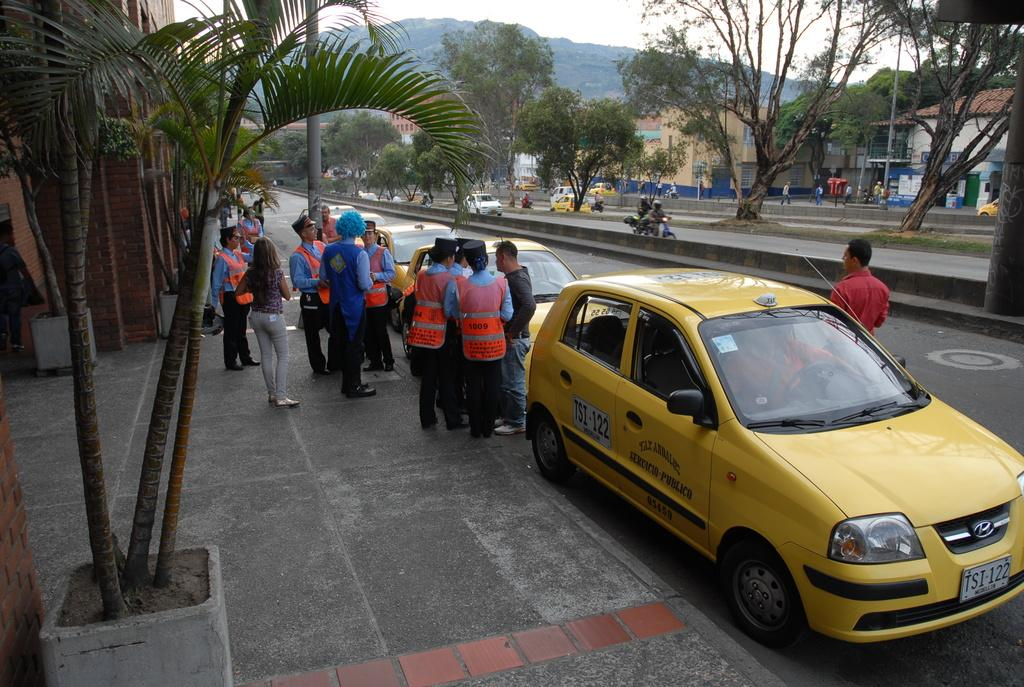<image>
Present a compact description of the photo's key features. A group of people stand behind taxi cab TSI-122. 